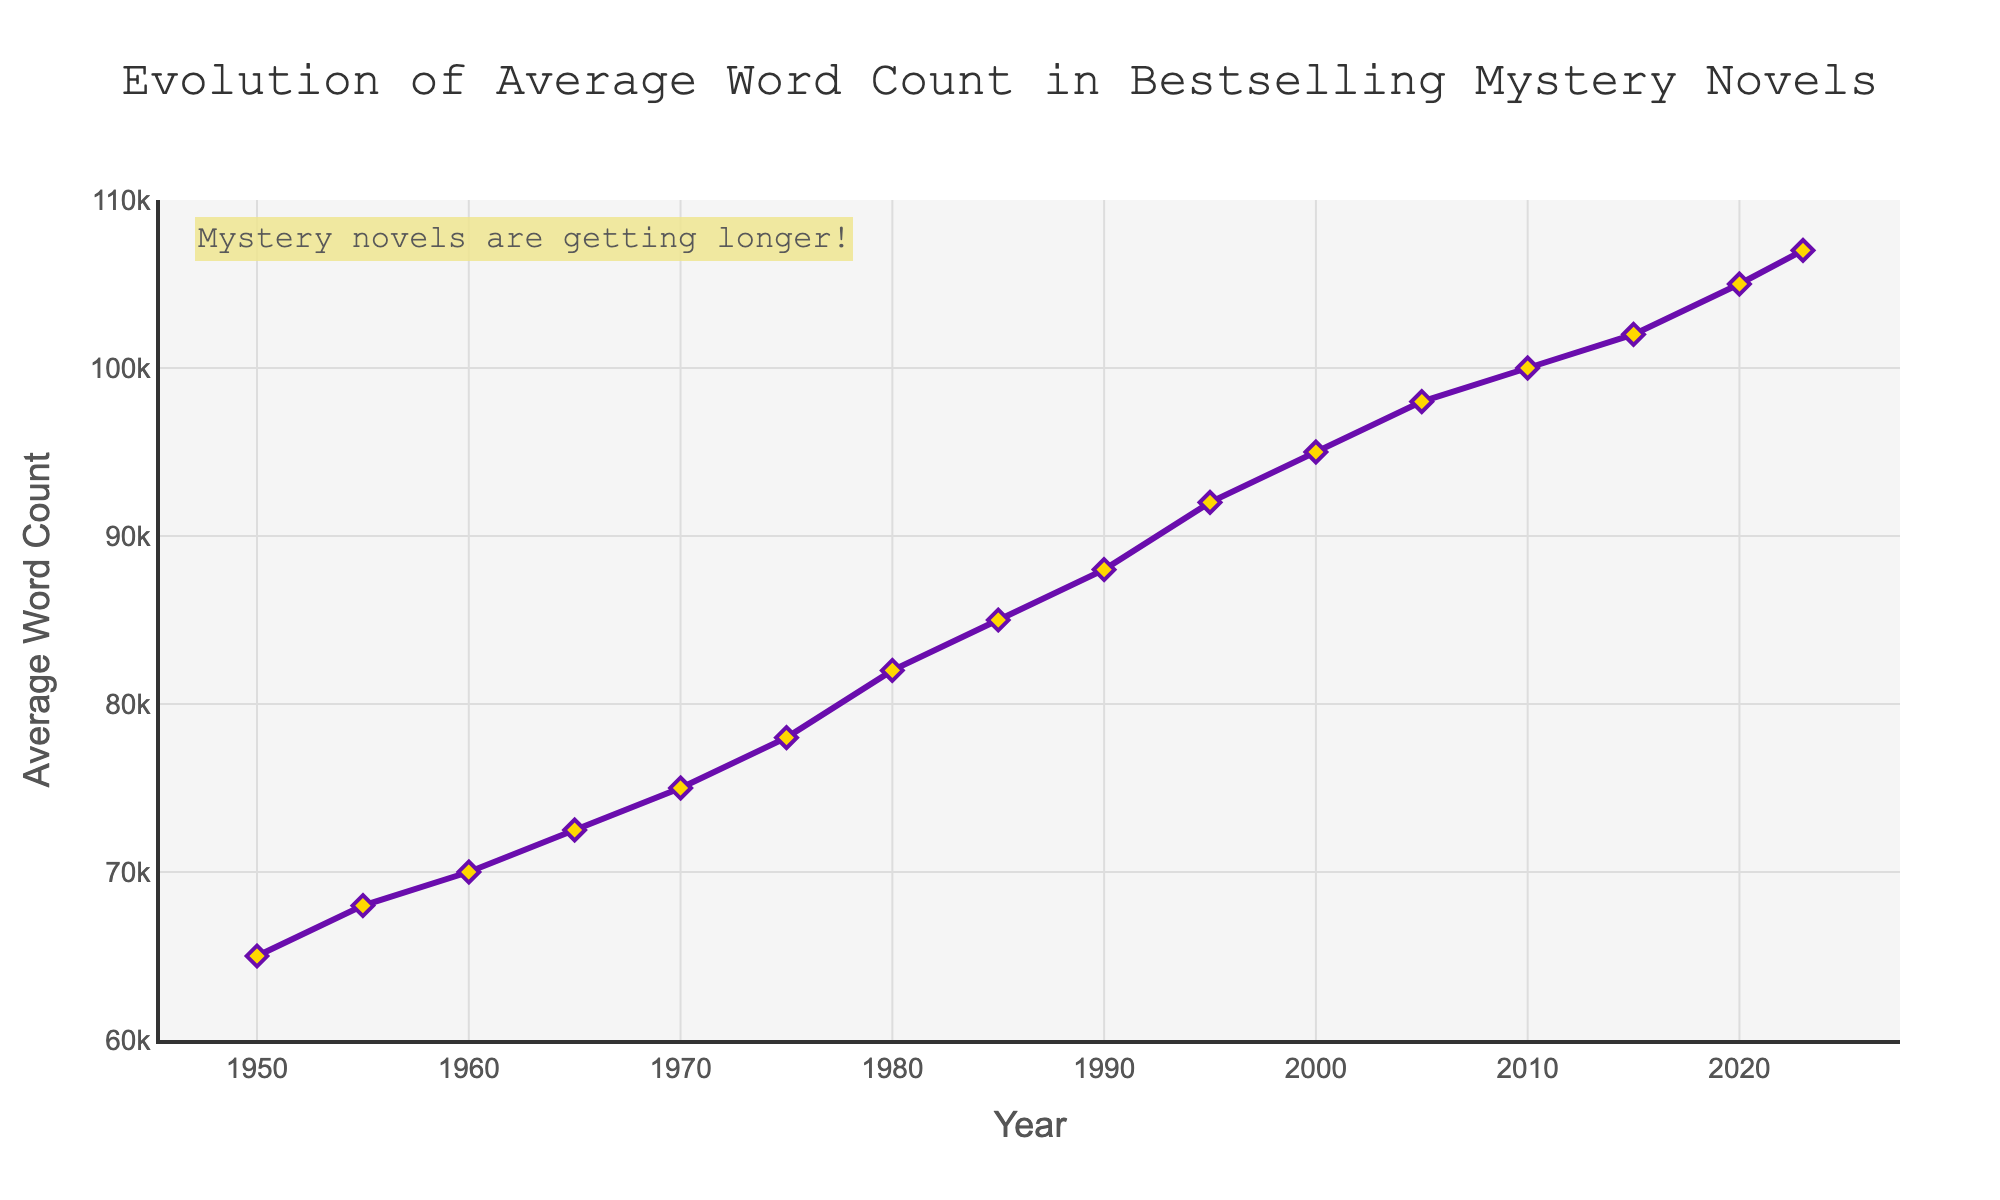What is the average word count in bestselling mystery novels in 1980? In 1980, the average word count can be directly read from the figure.
Answer: 82000 How much did the average word count increase from 1950 to 2000? Subtract the average word count in 1950 from that in 2000. 95000 (2000) - 65000 (1950) = 30000
Answer: 30000 During which decade did the average word count increase by 4000 words? Check the differences between each decade and find the one with a 4000-word increase. Between 1990 (88000) and 2000 (92000), the increase is 4000 words.
Answer: 1990s to 2000 By how much did the average word count change between 1975 and 1985? Subtract the average word count in 1975 (78000) from that in 1985 (85000). 85000 - 78000 = 7000
Answer: 7000 Between 1950 and 2023, in which year did the average word count exceed 90000 for the first time? Locate the initial year when the word count surpasses 90000. In 1995, the word count is 92000, which is the first instance above 90000.
Answer: 1995 Identify the year with the smallest increase in average word count compared to its preceding period. Compare two consecutive years and find the smallest difference. From 2015 (102000) to 2020 (105000), the increase is 3000, the smallest.
Answer: 2015-2020 What is the average word count in bestselling mystery novels for the year 2023, and how does it compare to the year 2010? Find the difference between the word counts of 2023 and 2010: 107000 (2023) - 100000 (2010) = 7000
Answer: 7000 Describe the trend in average word count from 1950 to 2023. The trend shows a steady increase in word count over the years, rising from 65000 in 1950 to 107000 in 2023, indicating that mystery novels have generally become longer.
Answer: Increasing How much higher is the average word count in 2023 compared to 1960? Subtract the average word count in 1960 (70000) from that in 2023 (107000). 107000 - 70000 = 37000
Answer: 37000 